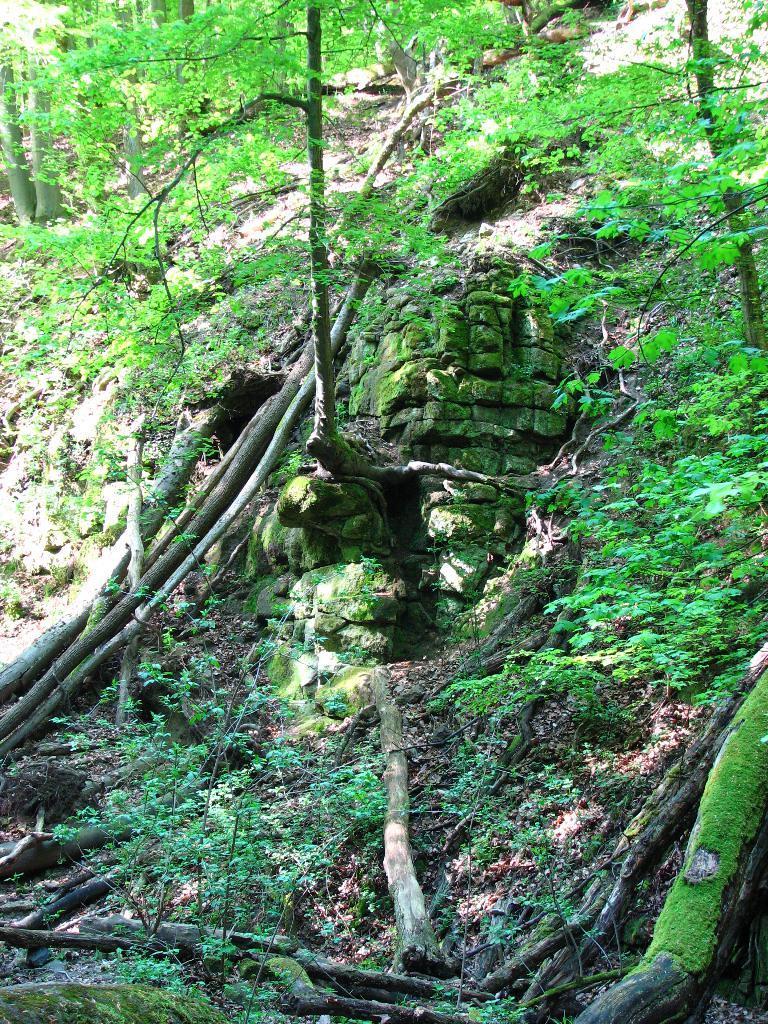Describe this image in one or two sentences. Here in this picture we can see a place, where the ground is covered with grass and we can also see some plants and trees present and we can see some branches present on the ground and we can also see some rock stones present. 